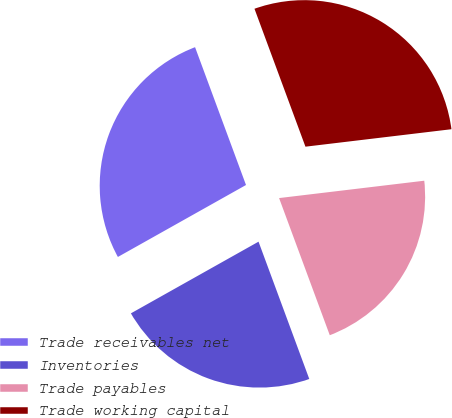<chart> <loc_0><loc_0><loc_500><loc_500><pie_chart><fcel>Trade receivables net<fcel>Inventories<fcel>Trade payables<fcel>Trade working capital<nl><fcel>27.51%<fcel>22.49%<fcel>21.26%<fcel>28.74%<nl></chart> 